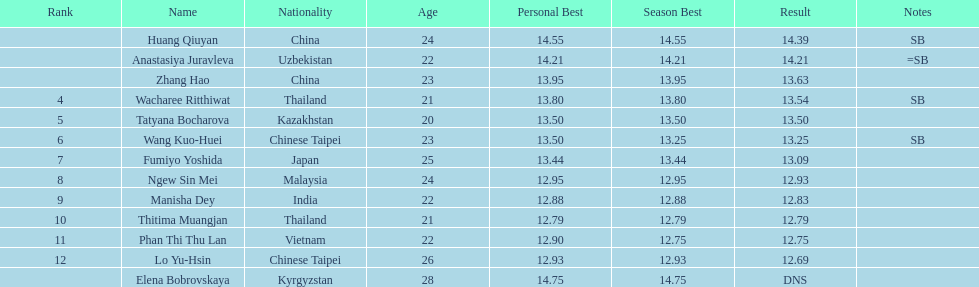How many athletes were from china? 2. 